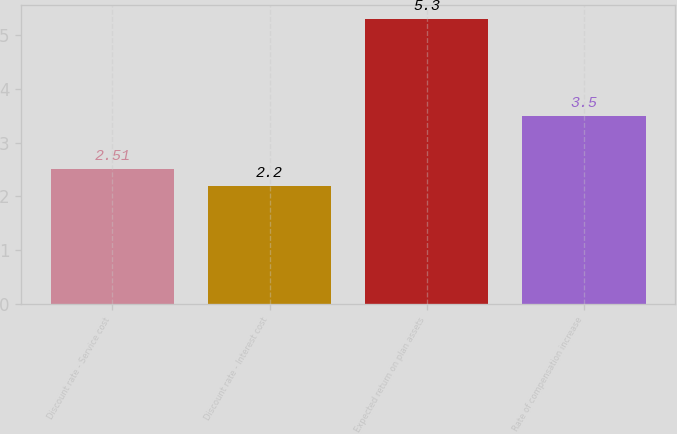<chart> <loc_0><loc_0><loc_500><loc_500><bar_chart><fcel>Discount rate - Service cost<fcel>Discount rate - Interest cost<fcel>Expected return on plan assets<fcel>Rate of compensation increase<nl><fcel>2.51<fcel>2.2<fcel>5.3<fcel>3.5<nl></chart> 